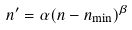<formula> <loc_0><loc_0><loc_500><loc_500>n ^ { \prime } = \alpha ( n - n _ { \min } ) ^ { \beta }</formula> 